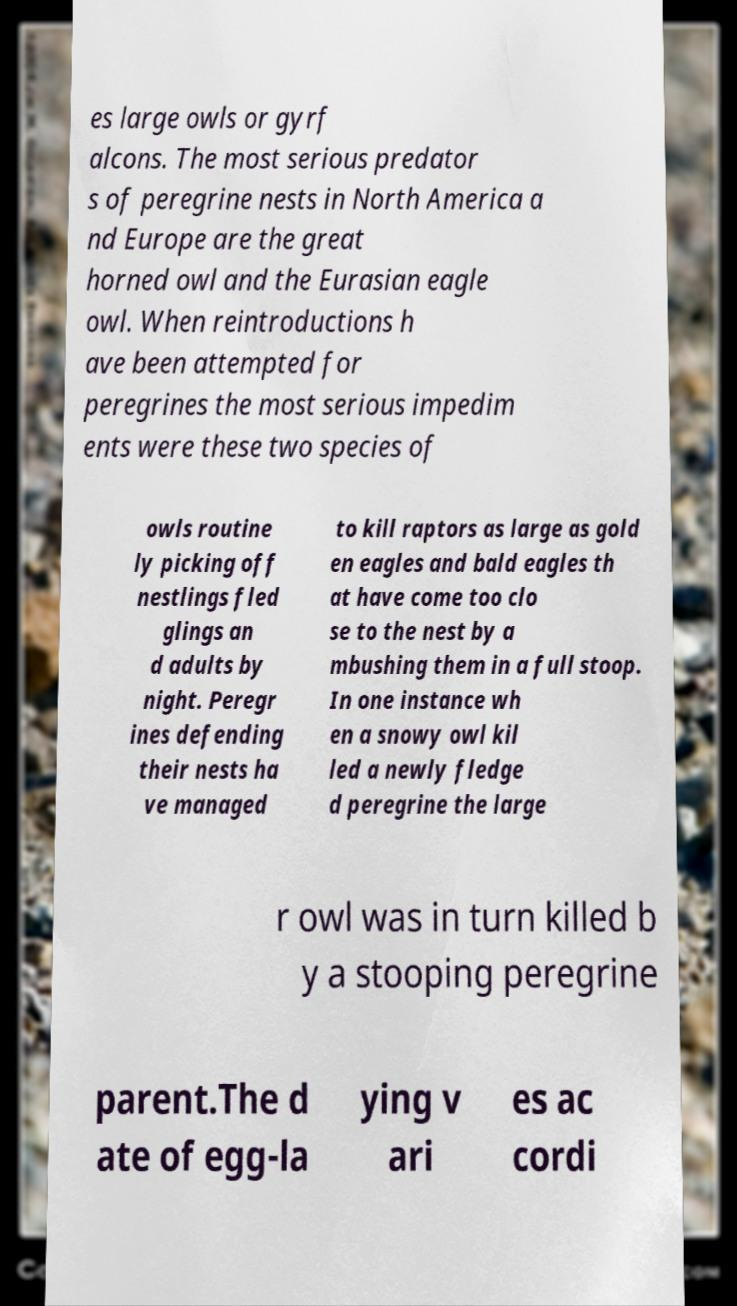What messages or text are displayed in this image? I need them in a readable, typed format. es large owls or gyrf alcons. The most serious predator s of peregrine nests in North America a nd Europe are the great horned owl and the Eurasian eagle owl. When reintroductions h ave been attempted for peregrines the most serious impedim ents were these two species of owls routine ly picking off nestlings fled glings an d adults by night. Peregr ines defending their nests ha ve managed to kill raptors as large as gold en eagles and bald eagles th at have come too clo se to the nest by a mbushing them in a full stoop. In one instance wh en a snowy owl kil led a newly fledge d peregrine the large r owl was in turn killed b y a stooping peregrine parent.The d ate of egg-la ying v ari es ac cordi 